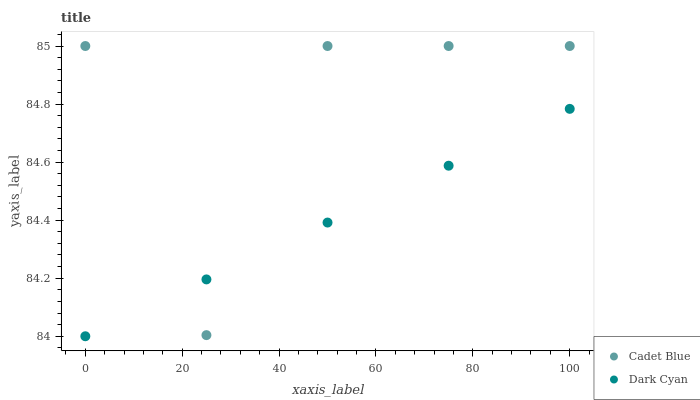Does Dark Cyan have the minimum area under the curve?
Answer yes or no. Yes. Does Cadet Blue have the maximum area under the curve?
Answer yes or no. Yes. Does Cadet Blue have the minimum area under the curve?
Answer yes or no. No. Is Dark Cyan the smoothest?
Answer yes or no. Yes. Is Cadet Blue the roughest?
Answer yes or no. Yes. Is Cadet Blue the smoothest?
Answer yes or no. No. Does Dark Cyan have the lowest value?
Answer yes or no. Yes. Does Cadet Blue have the lowest value?
Answer yes or no. No. Does Cadet Blue have the highest value?
Answer yes or no. Yes. Does Cadet Blue intersect Dark Cyan?
Answer yes or no. Yes. Is Cadet Blue less than Dark Cyan?
Answer yes or no. No. Is Cadet Blue greater than Dark Cyan?
Answer yes or no. No. 